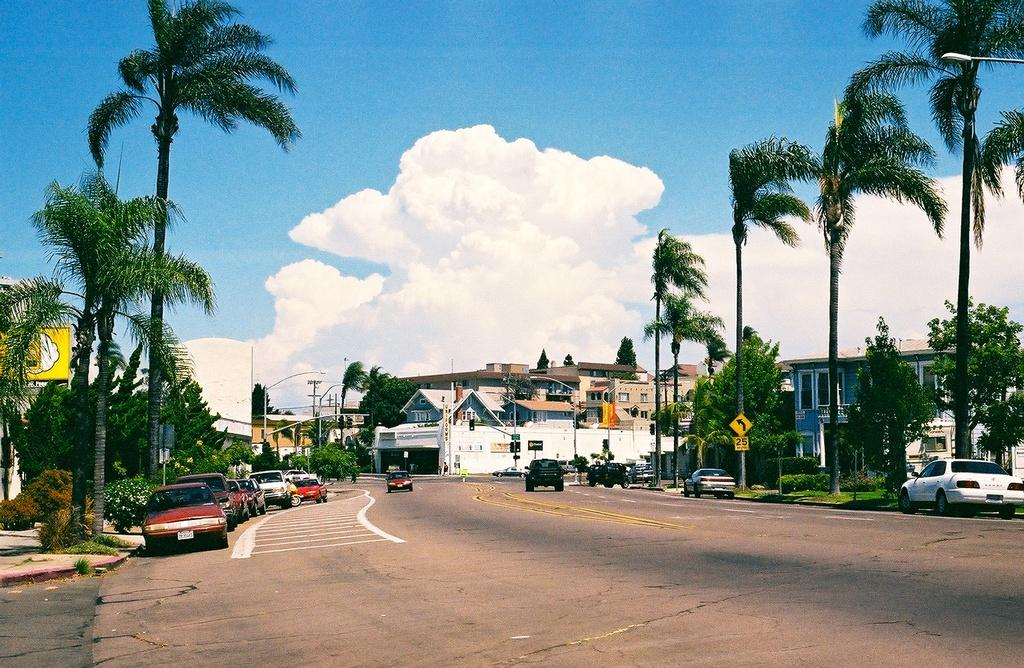What is the main feature in the middle of the image? There is a road in the middle of the image. What can be seen on either side of the road? There are vehicles on either side of the road. What type of vegetation is visible behind the road? Trees are present behind the road. What type of structures are visible behind the road? Buildings are visible behind the road. What is visible above the road? The sky is visible above the road. What can be seen in the sky? Clouds are present in the sky. Can you see a kitty playing with a farmer in the image? There is no kitty or farmer present in the image. Is there an airplane flying above the road in the image? There is no airplane visible in the image; only vehicles, trees, buildings, and clouds are present. 